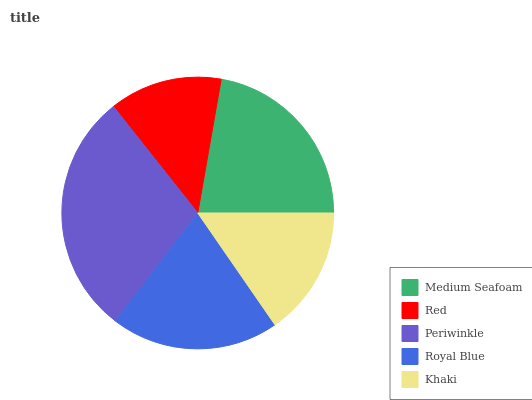Is Red the minimum?
Answer yes or no. Yes. Is Periwinkle the maximum?
Answer yes or no. Yes. Is Periwinkle the minimum?
Answer yes or no. No. Is Red the maximum?
Answer yes or no. No. Is Periwinkle greater than Red?
Answer yes or no. Yes. Is Red less than Periwinkle?
Answer yes or no. Yes. Is Red greater than Periwinkle?
Answer yes or no. No. Is Periwinkle less than Red?
Answer yes or no. No. Is Royal Blue the high median?
Answer yes or no. Yes. Is Royal Blue the low median?
Answer yes or no. Yes. Is Periwinkle the high median?
Answer yes or no. No. Is Medium Seafoam the low median?
Answer yes or no. No. 